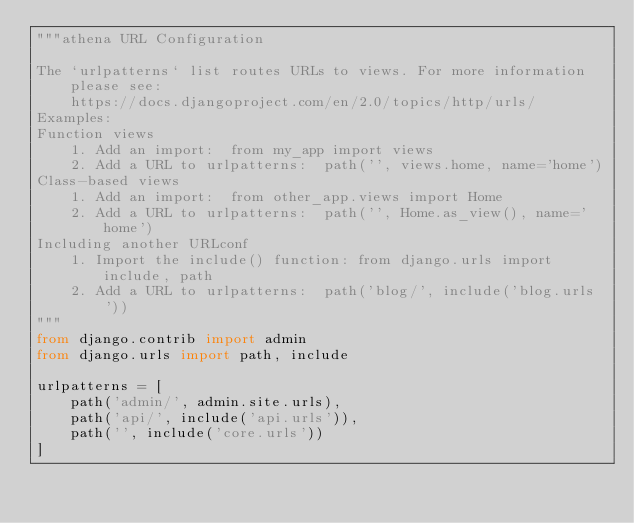<code> <loc_0><loc_0><loc_500><loc_500><_Python_>"""athena URL Configuration

The `urlpatterns` list routes URLs to views. For more information please see:
    https://docs.djangoproject.com/en/2.0/topics/http/urls/
Examples:
Function views
    1. Add an import:  from my_app import views
    2. Add a URL to urlpatterns:  path('', views.home, name='home')
Class-based views
    1. Add an import:  from other_app.views import Home
    2. Add a URL to urlpatterns:  path('', Home.as_view(), name='home')
Including another URLconf
    1. Import the include() function: from django.urls import include, path
    2. Add a URL to urlpatterns:  path('blog/', include('blog.urls'))
"""
from django.contrib import admin
from django.urls import path, include

urlpatterns = [
    path('admin/', admin.site.urls),
    path('api/', include('api.urls')),
    path('', include('core.urls'))
]
</code> 